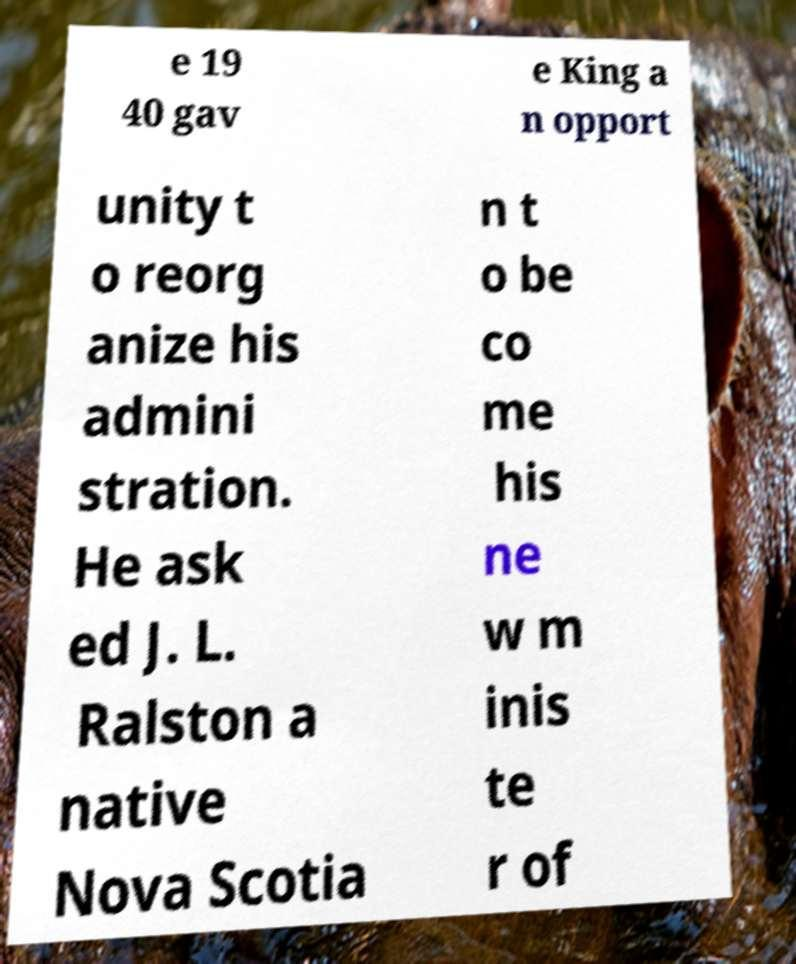Could you assist in decoding the text presented in this image and type it out clearly? e 19 40 gav e King a n opport unity t o reorg anize his admini stration. He ask ed J. L. Ralston a native Nova Scotia n t o be co me his ne w m inis te r of 